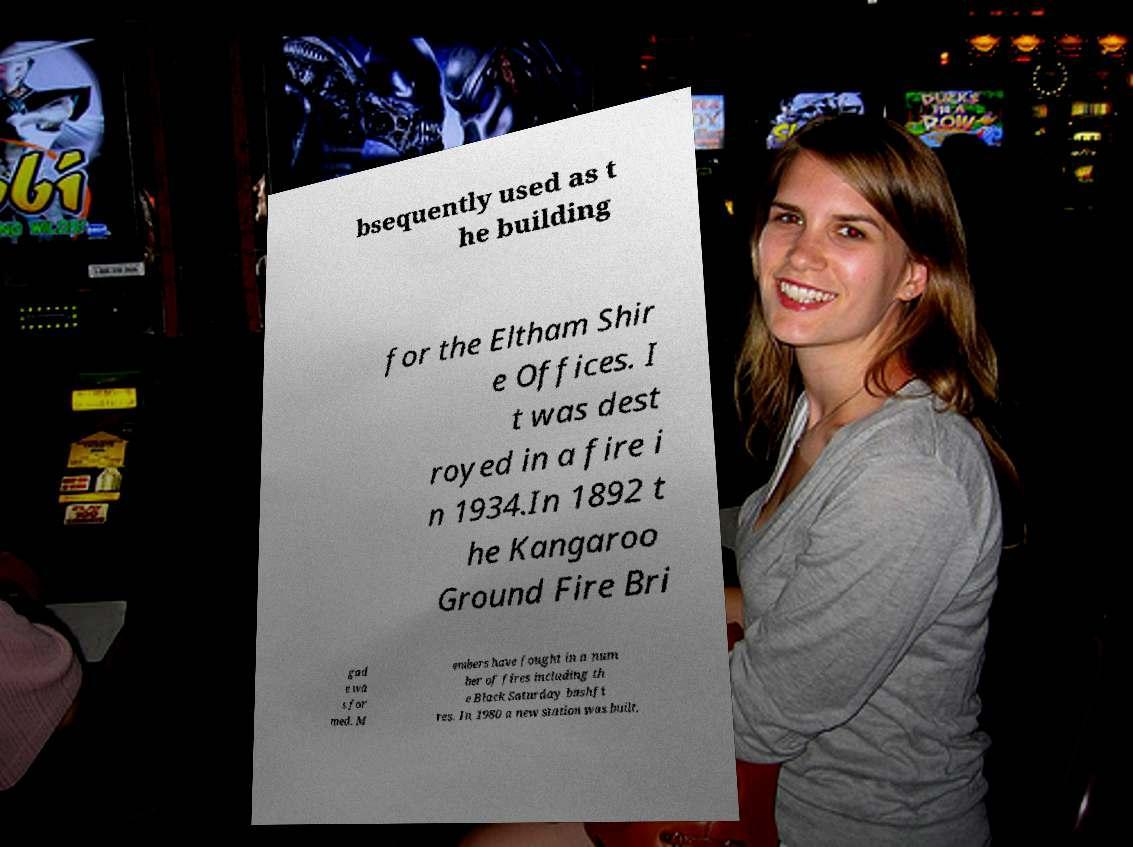There's text embedded in this image that I need extracted. Can you transcribe it verbatim? bsequently used as t he building for the Eltham Shir e Offices. I t was dest royed in a fire i n 1934.In 1892 t he Kangaroo Ground Fire Bri gad e wa s for med. M embers have fought in a num ber of fires including th e Black Saturday bushfi res. In 1980 a new station was built. 